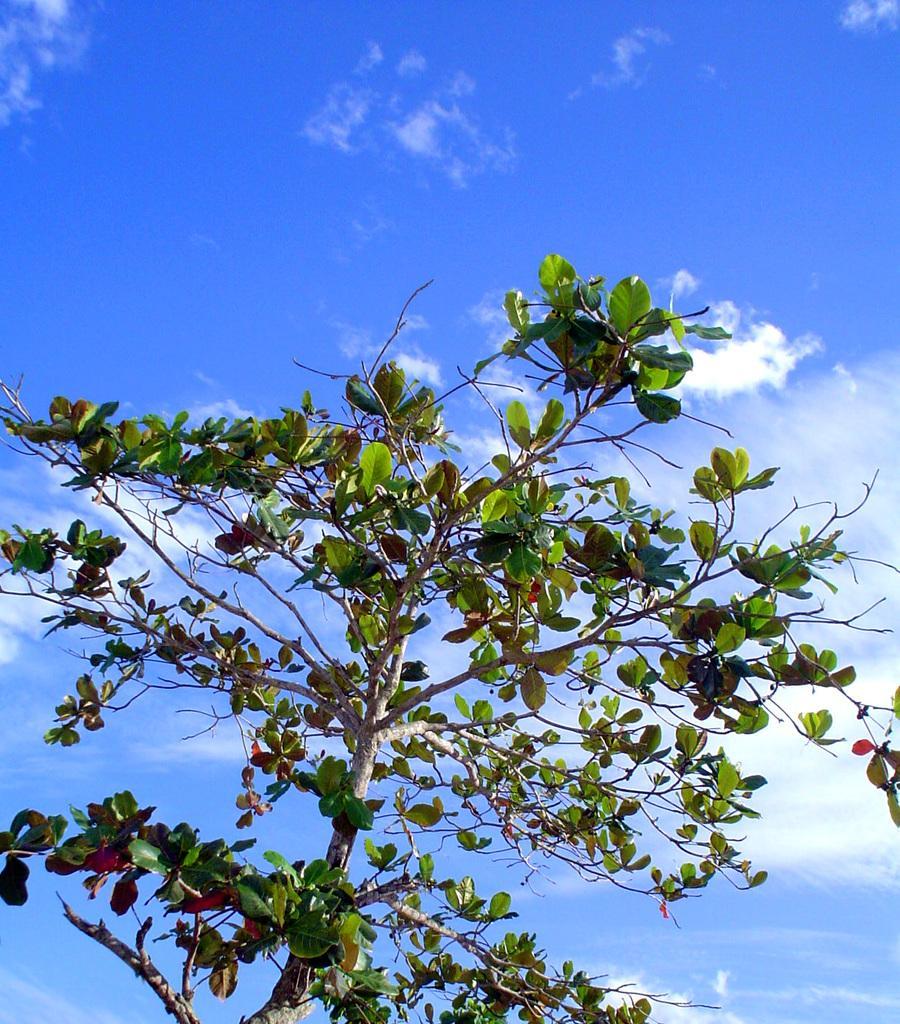Could you give a brief overview of what you see in this image? In this image I can see the plant and few green color leaves. The sky is in white and blue color. 